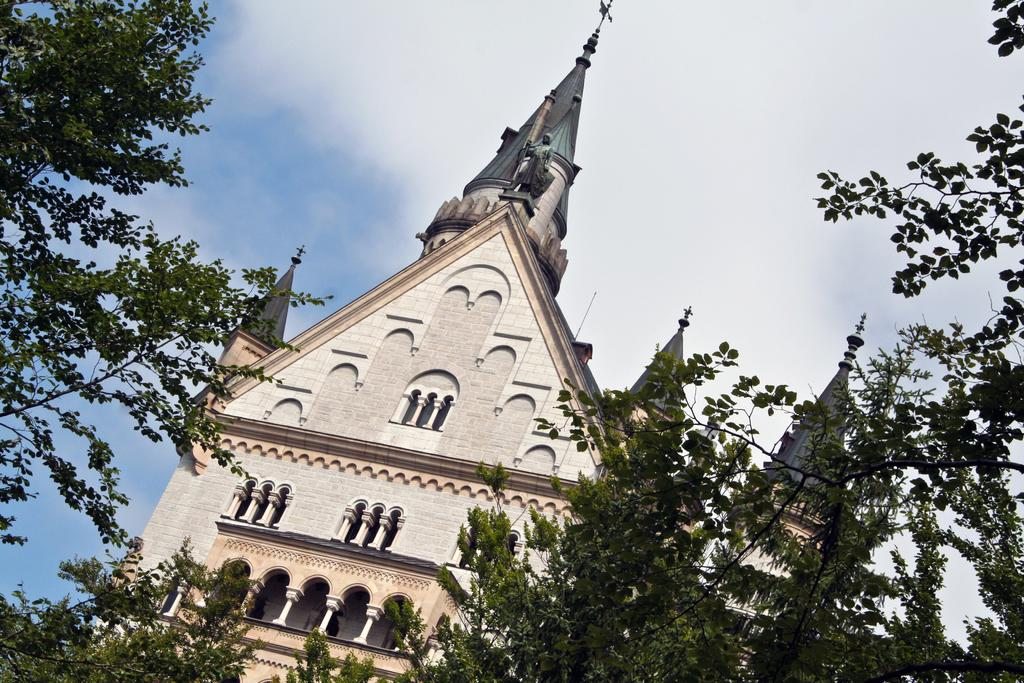What is the main subject of the image? There is a church at the center of the image. What can be seen in front of the church? There are trees in front of the church. What is visible in the background of the image? The sky is visible in the background of the image. What type of toy is being used during the test in the image? There is no toy or test present in the image; it features a church with trees in front and the sky in the background. 